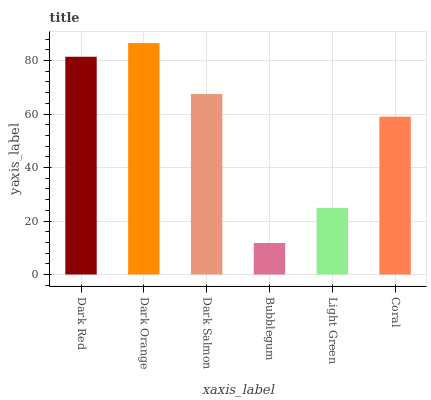Is Bubblegum the minimum?
Answer yes or no. Yes. Is Dark Orange the maximum?
Answer yes or no. Yes. Is Dark Salmon the minimum?
Answer yes or no. No. Is Dark Salmon the maximum?
Answer yes or no. No. Is Dark Orange greater than Dark Salmon?
Answer yes or no. Yes. Is Dark Salmon less than Dark Orange?
Answer yes or no. Yes. Is Dark Salmon greater than Dark Orange?
Answer yes or no. No. Is Dark Orange less than Dark Salmon?
Answer yes or no. No. Is Dark Salmon the high median?
Answer yes or no. Yes. Is Coral the low median?
Answer yes or no. Yes. Is Dark Red the high median?
Answer yes or no. No. Is Dark Orange the low median?
Answer yes or no. No. 